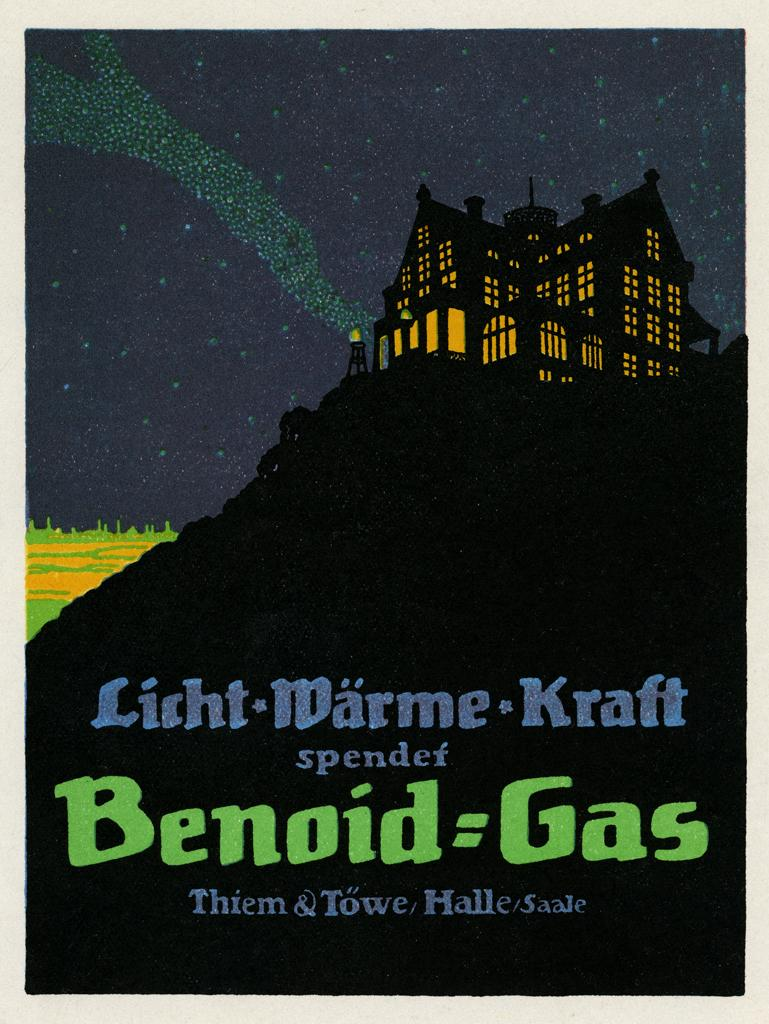Provide a one-sentence caption for the provided image. A poster for some work by Benoid Gas shows a house lit up at night. 